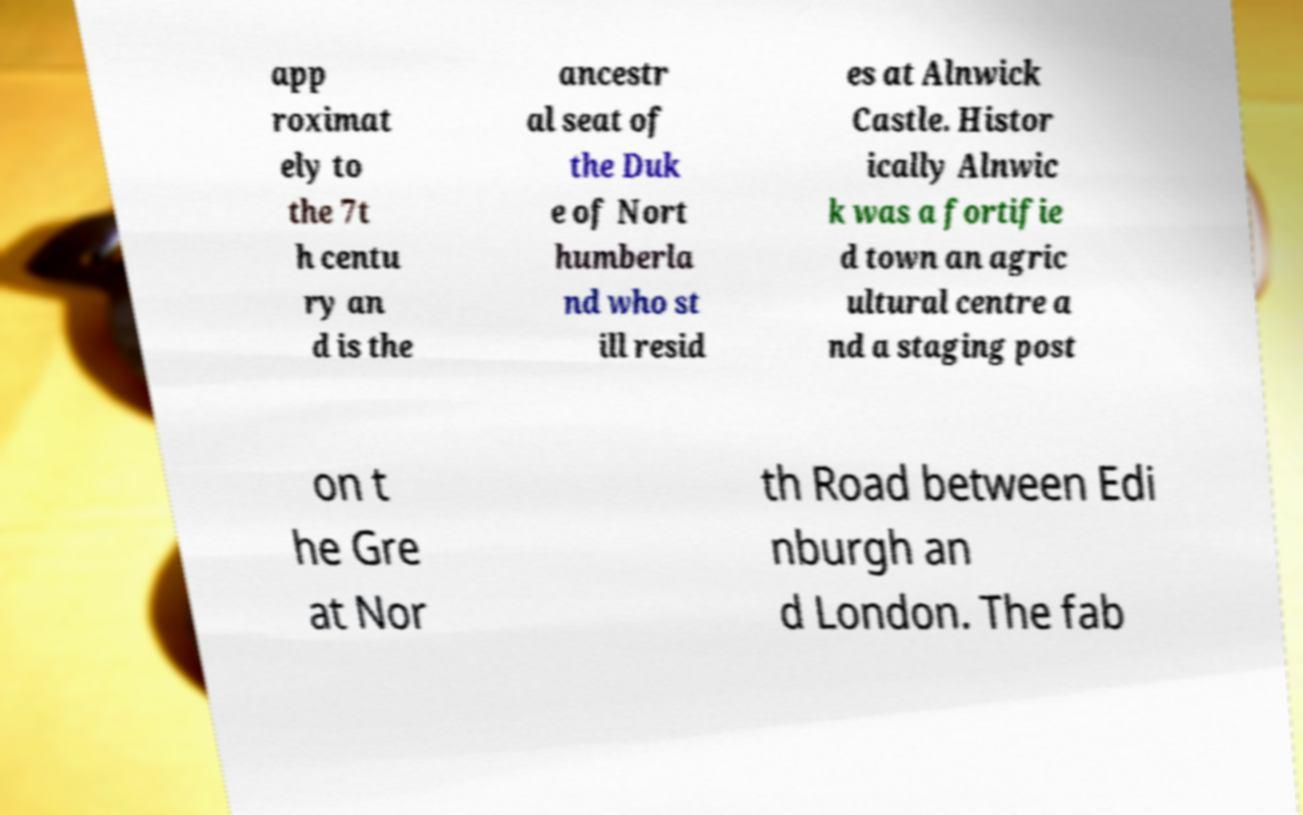Could you extract and type out the text from this image? app roximat ely to the 7t h centu ry an d is the ancestr al seat of the Duk e of Nort humberla nd who st ill resid es at Alnwick Castle. Histor ically Alnwic k was a fortifie d town an agric ultural centre a nd a staging post on t he Gre at Nor th Road between Edi nburgh an d London. The fab 